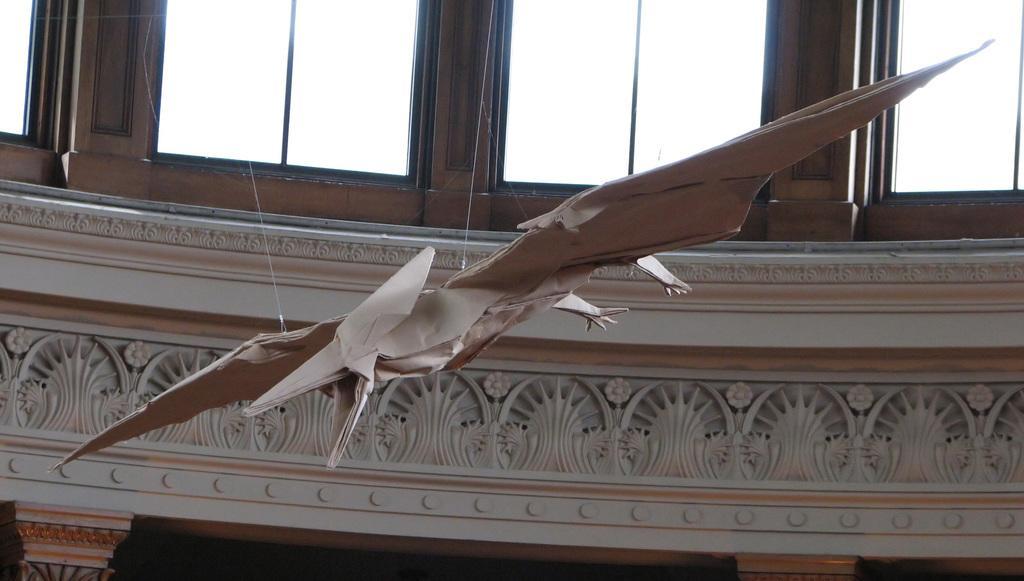How would you summarize this image in a sentence or two? Here we can see a paper craft. In the background there are glasses and a wall. 